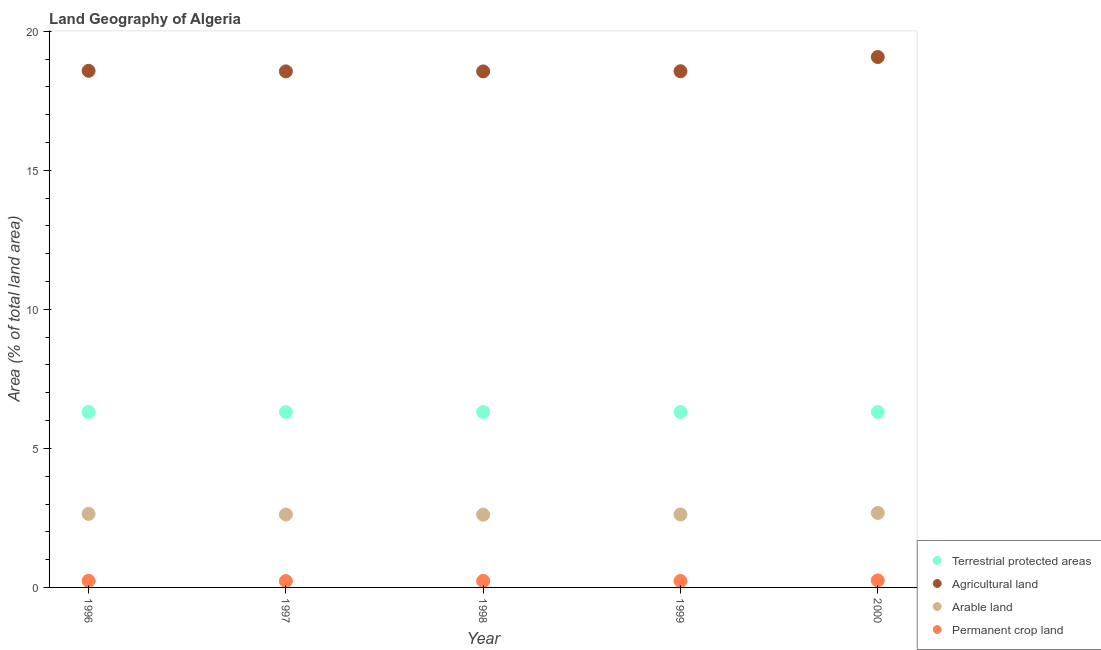What is the percentage of area under agricultural land in 2000?
Offer a terse response. 19.08. Across all years, what is the maximum percentage of area under permanent crop land?
Your response must be concise. 0.25. Across all years, what is the minimum percentage of land under terrestrial protection?
Provide a short and direct response. 6.31. In which year was the percentage of area under arable land maximum?
Keep it short and to the point. 2000. In which year was the percentage of land under terrestrial protection minimum?
Your answer should be very brief. 2000. What is the total percentage of area under arable land in the graph?
Your answer should be compact. 13.19. What is the difference between the percentage of area under agricultural land in 1997 and that in 1998?
Give a very brief answer. 0. What is the difference between the percentage of area under agricultural land in 1997 and the percentage of area under arable land in 2000?
Keep it short and to the point. 15.88. What is the average percentage of land under terrestrial protection per year?
Offer a terse response. 6.31. In the year 1996, what is the difference between the percentage of area under permanent crop land and percentage of area under arable land?
Give a very brief answer. -2.41. In how many years, is the percentage of land under terrestrial protection greater than 4 %?
Provide a short and direct response. 5. What is the ratio of the percentage of area under arable land in 1997 to that in 1998?
Offer a very short reply. 1. Is the percentage of area under arable land in 1998 less than that in 2000?
Your answer should be very brief. Yes. Is the difference between the percentage of area under arable land in 1997 and 1998 greater than the difference between the percentage of area under agricultural land in 1997 and 1998?
Provide a short and direct response. Yes. What is the difference between the highest and the second highest percentage of area under arable land?
Provide a short and direct response. 0.03. What is the difference between the highest and the lowest percentage of area under permanent crop land?
Provide a succinct answer. 0.02. In how many years, is the percentage of area under agricultural land greater than the average percentage of area under agricultural land taken over all years?
Give a very brief answer. 1. Is the sum of the percentage of area under permanent crop land in 1997 and 1998 greater than the maximum percentage of land under terrestrial protection across all years?
Offer a terse response. No. Is it the case that in every year, the sum of the percentage of area under permanent crop land and percentage of area under agricultural land is greater than the sum of percentage of land under terrestrial protection and percentage of area under arable land?
Ensure brevity in your answer.  No. Is it the case that in every year, the sum of the percentage of land under terrestrial protection and percentage of area under agricultural land is greater than the percentage of area under arable land?
Your answer should be compact. Yes. How many dotlines are there?
Offer a very short reply. 4. What is the difference between two consecutive major ticks on the Y-axis?
Your answer should be compact. 5. Where does the legend appear in the graph?
Keep it short and to the point. Bottom right. How are the legend labels stacked?
Your answer should be very brief. Vertical. What is the title of the graph?
Provide a short and direct response. Land Geography of Algeria. Does "Belgium" appear as one of the legend labels in the graph?
Provide a short and direct response. No. What is the label or title of the X-axis?
Provide a short and direct response. Year. What is the label or title of the Y-axis?
Give a very brief answer. Area (% of total land area). What is the Area (% of total land area) in Terrestrial protected areas in 1996?
Provide a succinct answer. 6.31. What is the Area (% of total land area) in Agricultural land in 1996?
Give a very brief answer. 18.58. What is the Area (% of total land area) of Arable land in 1996?
Provide a succinct answer. 2.65. What is the Area (% of total land area) in Permanent crop land in 1996?
Provide a succinct answer. 0.24. What is the Area (% of total land area) of Terrestrial protected areas in 1997?
Your answer should be very brief. 6.31. What is the Area (% of total land area) in Agricultural land in 1997?
Give a very brief answer. 18.56. What is the Area (% of total land area) of Arable land in 1997?
Ensure brevity in your answer.  2.62. What is the Area (% of total land area) of Permanent crop land in 1997?
Your response must be concise. 0.23. What is the Area (% of total land area) in Terrestrial protected areas in 1998?
Your answer should be very brief. 6.31. What is the Area (% of total land area) in Agricultural land in 1998?
Make the answer very short. 18.56. What is the Area (% of total land area) in Arable land in 1998?
Give a very brief answer. 2.62. What is the Area (% of total land area) in Permanent crop land in 1998?
Provide a succinct answer. 0.23. What is the Area (% of total land area) of Terrestrial protected areas in 1999?
Give a very brief answer. 6.31. What is the Area (% of total land area) of Agricultural land in 1999?
Offer a very short reply. 18.56. What is the Area (% of total land area) in Arable land in 1999?
Provide a succinct answer. 2.62. What is the Area (% of total land area) in Permanent crop land in 1999?
Your answer should be very brief. 0.23. What is the Area (% of total land area) in Terrestrial protected areas in 2000?
Provide a short and direct response. 6.31. What is the Area (% of total land area) in Agricultural land in 2000?
Your response must be concise. 19.08. What is the Area (% of total land area) of Arable land in 2000?
Ensure brevity in your answer.  2.68. What is the Area (% of total land area) of Permanent crop land in 2000?
Offer a very short reply. 0.25. Across all years, what is the maximum Area (% of total land area) in Terrestrial protected areas?
Your answer should be compact. 6.31. Across all years, what is the maximum Area (% of total land area) of Agricultural land?
Provide a short and direct response. 19.08. Across all years, what is the maximum Area (% of total land area) in Arable land?
Offer a terse response. 2.68. Across all years, what is the maximum Area (% of total land area) of Permanent crop land?
Provide a short and direct response. 0.25. Across all years, what is the minimum Area (% of total land area) of Terrestrial protected areas?
Provide a succinct answer. 6.31. Across all years, what is the minimum Area (% of total land area) of Agricultural land?
Offer a very short reply. 18.56. Across all years, what is the minimum Area (% of total land area) in Arable land?
Give a very brief answer. 2.62. Across all years, what is the minimum Area (% of total land area) of Permanent crop land?
Your answer should be very brief. 0.23. What is the total Area (% of total land area) in Terrestrial protected areas in the graph?
Keep it short and to the point. 31.54. What is the total Area (% of total land area) of Agricultural land in the graph?
Provide a succinct answer. 93.34. What is the total Area (% of total land area) in Arable land in the graph?
Ensure brevity in your answer.  13.19. What is the total Area (% of total land area) in Permanent crop land in the graph?
Offer a terse response. 1.18. What is the difference between the Area (% of total land area) of Terrestrial protected areas in 1996 and that in 1997?
Provide a short and direct response. 0. What is the difference between the Area (% of total land area) of Agricultural land in 1996 and that in 1997?
Offer a very short reply. 0.02. What is the difference between the Area (% of total land area) of Arable land in 1996 and that in 1997?
Ensure brevity in your answer.  0.02. What is the difference between the Area (% of total land area) of Permanent crop land in 1996 and that in 1997?
Your response must be concise. 0.01. What is the difference between the Area (% of total land area) in Agricultural land in 1996 and that in 1998?
Give a very brief answer. 0.02. What is the difference between the Area (% of total land area) in Arable land in 1996 and that in 1998?
Give a very brief answer. 0.03. What is the difference between the Area (% of total land area) in Permanent crop land in 1996 and that in 1998?
Give a very brief answer. 0. What is the difference between the Area (% of total land area) in Terrestrial protected areas in 1996 and that in 1999?
Give a very brief answer. 0. What is the difference between the Area (% of total land area) in Agricultural land in 1996 and that in 1999?
Make the answer very short. 0.01. What is the difference between the Area (% of total land area) of Arable land in 1996 and that in 1999?
Ensure brevity in your answer.  0.02. What is the difference between the Area (% of total land area) of Permanent crop land in 1996 and that in 1999?
Your answer should be compact. 0.01. What is the difference between the Area (% of total land area) of Agricultural land in 1996 and that in 2000?
Your response must be concise. -0.5. What is the difference between the Area (% of total land area) in Arable land in 1996 and that in 2000?
Your answer should be compact. -0.03. What is the difference between the Area (% of total land area) of Permanent crop land in 1996 and that in 2000?
Give a very brief answer. -0.02. What is the difference between the Area (% of total land area) in Arable land in 1997 and that in 1998?
Offer a terse response. 0. What is the difference between the Area (% of total land area) of Permanent crop land in 1997 and that in 1998?
Your response must be concise. -0. What is the difference between the Area (% of total land area) in Terrestrial protected areas in 1997 and that in 1999?
Your answer should be compact. 0. What is the difference between the Area (% of total land area) of Agricultural land in 1997 and that in 1999?
Give a very brief answer. -0.01. What is the difference between the Area (% of total land area) in Arable land in 1997 and that in 1999?
Provide a short and direct response. -0. What is the difference between the Area (% of total land area) in Permanent crop land in 1997 and that in 1999?
Keep it short and to the point. -0. What is the difference between the Area (% of total land area) in Agricultural land in 1997 and that in 2000?
Your answer should be compact. -0.52. What is the difference between the Area (% of total land area) of Arable land in 1997 and that in 2000?
Your answer should be compact. -0.06. What is the difference between the Area (% of total land area) of Permanent crop land in 1997 and that in 2000?
Make the answer very short. -0.02. What is the difference between the Area (% of total land area) in Terrestrial protected areas in 1998 and that in 1999?
Offer a terse response. 0. What is the difference between the Area (% of total land area) in Agricultural land in 1998 and that in 1999?
Your answer should be very brief. -0.01. What is the difference between the Area (% of total land area) of Arable land in 1998 and that in 1999?
Offer a very short reply. -0.01. What is the difference between the Area (% of total land area) in Permanent crop land in 1998 and that in 1999?
Ensure brevity in your answer.  0. What is the difference between the Area (% of total land area) of Agricultural land in 1998 and that in 2000?
Provide a succinct answer. -0.52. What is the difference between the Area (% of total land area) in Arable land in 1998 and that in 2000?
Offer a terse response. -0.06. What is the difference between the Area (% of total land area) in Permanent crop land in 1998 and that in 2000?
Provide a succinct answer. -0.02. What is the difference between the Area (% of total land area) of Agricultural land in 1999 and that in 2000?
Make the answer very short. -0.51. What is the difference between the Area (% of total land area) in Arable land in 1999 and that in 2000?
Provide a short and direct response. -0.06. What is the difference between the Area (% of total land area) of Permanent crop land in 1999 and that in 2000?
Make the answer very short. -0.02. What is the difference between the Area (% of total land area) of Terrestrial protected areas in 1996 and the Area (% of total land area) of Agricultural land in 1997?
Make the answer very short. -12.25. What is the difference between the Area (% of total land area) in Terrestrial protected areas in 1996 and the Area (% of total land area) in Arable land in 1997?
Your answer should be very brief. 3.69. What is the difference between the Area (% of total land area) of Terrestrial protected areas in 1996 and the Area (% of total land area) of Permanent crop land in 1997?
Provide a short and direct response. 6.08. What is the difference between the Area (% of total land area) of Agricultural land in 1996 and the Area (% of total land area) of Arable land in 1997?
Keep it short and to the point. 15.96. What is the difference between the Area (% of total land area) of Agricultural land in 1996 and the Area (% of total land area) of Permanent crop land in 1997?
Your answer should be compact. 18.35. What is the difference between the Area (% of total land area) of Arable land in 1996 and the Area (% of total land area) of Permanent crop land in 1997?
Make the answer very short. 2.42. What is the difference between the Area (% of total land area) in Terrestrial protected areas in 1996 and the Area (% of total land area) in Agricultural land in 1998?
Ensure brevity in your answer.  -12.25. What is the difference between the Area (% of total land area) of Terrestrial protected areas in 1996 and the Area (% of total land area) of Arable land in 1998?
Keep it short and to the point. 3.69. What is the difference between the Area (% of total land area) in Terrestrial protected areas in 1996 and the Area (% of total land area) in Permanent crop land in 1998?
Make the answer very short. 6.08. What is the difference between the Area (% of total land area) in Agricultural land in 1996 and the Area (% of total land area) in Arable land in 1998?
Your answer should be compact. 15.96. What is the difference between the Area (% of total land area) of Agricultural land in 1996 and the Area (% of total land area) of Permanent crop land in 1998?
Ensure brevity in your answer.  18.35. What is the difference between the Area (% of total land area) in Arable land in 1996 and the Area (% of total land area) in Permanent crop land in 1998?
Offer a terse response. 2.41. What is the difference between the Area (% of total land area) in Terrestrial protected areas in 1996 and the Area (% of total land area) in Agricultural land in 1999?
Offer a very short reply. -12.26. What is the difference between the Area (% of total land area) of Terrestrial protected areas in 1996 and the Area (% of total land area) of Arable land in 1999?
Your answer should be compact. 3.69. What is the difference between the Area (% of total land area) of Terrestrial protected areas in 1996 and the Area (% of total land area) of Permanent crop land in 1999?
Provide a short and direct response. 6.08. What is the difference between the Area (% of total land area) of Agricultural land in 1996 and the Area (% of total land area) of Arable land in 1999?
Offer a terse response. 15.96. What is the difference between the Area (% of total land area) of Agricultural land in 1996 and the Area (% of total land area) of Permanent crop land in 1999?
Provide a short and direct response. 18.35. What is the difference between the Area (% of total land area) in Arable land in 1996 and the Area (% of total land area) in Permanent crop land in 1999?
Ensure brevity in your answer.  2.41. What is the difference between the Area (% of total land area) of Terrestrial protected areas in 1996 and the Area (% of total land area) of Agricultural land in 2000?
Ensure brevity in your answer.  -12.77. What is the difference between the Area (% of total land area) in Terrestrial protected areas in 1996 and the Area (% of total land area) in Arable land in 2000?
Your answer should be very brief. 3.63. What is the difference between the Area (% of total land area) of Terrestrial protected areas in 1996 and the Area (% of total land area) of Permanent crop land in 2000?
Your answer should be compact. 6.06. What is the difference between the Area (% of total land area) of Agricultural land in 1996 and the Area (% of total land area) of Arable land in 2000?
Your answer should be very brief. 15.9. What is the difference between the Area (% of total land area) of Agricultural land in 1996 and the Area (% of total land area) of Permanent crop land in 2000?
Give a very brief answer. 18.33. What is the difference between the Area (% of total land area) in Arable land in 1996 and the Area (% of total land area) in Permanent crop land in 2000?
Your answer should be compact. 2.39. What is the difference between the Area (% of total land area) in Terrestrial protected areas in 1997 and the Area (% of total land area) in Agricultural land in 1998?
Offer a terse response. -12.25. What is the difference between the Area (% of total land area) of Terrestrial protected areas in 1997 and the Area (% of total land area) of Arable land in 1998?
Provide a succinct answer. 3.69. What is the difference between the Area (% of total land area) in Terrestrial protected areas in 1997 and the Area (% of total land area) in Permanent crop land in 1998?
Make the answer very short. 6.08. What is the difference between the Area (% of total land area) of Agricultural land in 1997 and the Area (% of total land area) of Arable land in 1998?
Make the answer very short. 15.94. What is the difference between the Area (% of total land area) of Agricultural land in 1997 and the Area (% of total land area) of Permanent crop land in 1998?
Offer a very short reply. 18.33. What is the difference between the Area (% of total land area) of Arable land in 1997 and the Area (% of total land area) of Permanent crop land in 1998?
Ensure brevity in your answer.  2.39. What is the difference between the Area (% of total land area) in Terrestrial protected areas in 1997 and the Area (% of total land area) in Agricultural land in 1999?
Your answer should be compact. -12.26. What is the difference between the Area (% of total land area) of Terrestrial protected areas in 1997 and the Area (% of total land area) of Arable land in 1999?
Offer a very short reply. 3.69. What is the difference between the Area (% of total land area) in Terrestrial protected areas in 1997 and the Area (% of total land area) in Permanent crop land in 1999?
Your answer should be very brief. 6.08. What is the difference between the Area (% of total land area) of Agricultural land in 1997 and the Area (% of total land area) of Arable land in 1999?
Make the answer very short. 15.94. What is the difference between the Area (% of total land area) in Agricultural land in 1997 and the Area (% of total land area) in Permanent crop land in 1999?
Make the answer very short. 18.33. What is the difference between the Area (% of total land area) in Arable land in 1997 and the Area (% of total land area) in Permanent crop land in 1999?
Your answer should be very brief. 2.39. What is the difference between the Area (% of total land area) of Terrestrial protected areas in 1997 and the Area (% of total land area) of Agricultural land in 2000?
Your answer should be very brief. -12.77. What is the difference between the Area (% of total land area) of Terrestrial protected areas in 1997 and the Area (% of total land area) of Arable land in 2000?
Your response must be concise. 3.63. What is the difference between the Area (% of total land area) in Terrestrial protected areas in 1997 and the Area (% of total land area) in Permanent crop land in 2000?
Your answer should be very brief. 6.06. What is the difference between the Area (% of total land area) of Agricultural land in 1997 and the Area (% of total land area) of Arable land in 2000?
Provide a succinct answer. 15.88. What is the difference between the Area (% of total land area) of Agricultural land in 1997 and the Area (% of total land area) of Permanent crop land in 2000?
Make the answer very short. 18.31. What is the difference between the Area (% of total land area) of Arable land in 1997 and the Area (% of total land area) of Permanent crop land in 2000?
Give a very brief answer. 2.37. What is the difference between the Area (% of total land area) of Terrestrial protected areas in 1998 and the Area (% of total land area) of Agricultural land in 1999?
Provide a short and direct response. -12.26. What is the difference between the Area (% of total land area) of Terrestrial protected areas in 1998 and the Area (% of total land area) of Arable land in 1999?
Your response must be concise. 3.69. What is the difference between the Area (% of total land area) of Terrestrial protected areas in 1998 and the Area (% of total land area) of Permanent crop land in 1999?
Your answer should be compact. 6.08. What is the difference between the Area (% of total land area) of Agricultural land in 1998 and the Area (% of total land area) of Arable land in 1999?
Your response must be concise. 15.94. What is the difference between the Area (% of total land area) in Agricultural land in 1998 and the Area (% of total land area) in Permanent crop land in 1999?
Offer a terse response. 18.33. What is the difference between the Area (% of total land area) of Arable land in 1998 and the Area (% of total land area) of Permanent crop land in 1999?
Your response must be concise. 2.39. What is the difference between the Area (% of total land area) of Terrestrial protected areas in 1998 and the Area (% of total land area) of Agricultural land in 2000?
Offer a very short reply. -12.77. What is the difference between the Area (% of total land area) in Terrestrial protected areas in 1998 and the Area (% of total land area) in Arable land in 2000?
Offer a terse response. 3.63. What is the difference between the Area (% of total land area) in Terrestrial protected areas in 1998 and the Area (% of total land area) in Permanent crop land in 2000?
Your answer should be compact. 6.06. What is the difference between the Area (% of total land area) in Agricultural land in 1998 and the Area (% of total land area) in Arable land in 2000?
Keep it short and to the point. 15.88. What is the difference between the Area (% of total land area) in Agricultural land in 1998 and the Area (% of total land area) in Permanent crop land in 2000?
Provide a short and direct response. 18.31. What is the difference between the Area (% of total land area) of Arable land in 1998 and the Area (% of total land area) of Permanent crop land in 2000?
Keep it short and to the point. 2.36. What is the difference between the Area (% of total land area) in Terrestrial protected areas in 1999 and the Area (% of total land area) in Agricultural land in 2000?
Keep it short and to the point. -12.77. What is the difference between the Area (% of total land area) of Terrestrial protected areas in 1999 and the Area (% of total land area) of Arable land in 2000?
Offer a very short reply. 3.63. What is the difference between the Area (% of total land area) in Terrestrial protected areas in 1999 and the Area (% of total land area) in Permanent crop land in 2000?
Your answer should be very brief. 6.06. What is the difference between the Area (% of total land area) in Agricultural land in 1999 and the Area (% of total land area) in Arable land in 2000?
Keep it short and to the point. 15.89. What is the difference between the Area (% of total land area) in Agricultural land in 1999 and the Area (% of total land area) in Permanent crop land in 2000?
Offer a terse response. 18.31. What is the difference between the Area (% of total land area) of Arable land in 1999 and the Area (% of total land area) of Permanent crop land in 2000?
Your answer should be compact. 2.37. What is the average Area (% of total land area) of Terrestrial protected areas per year?
Keep it short and to the point. 6.31. What is the average Area (% of total land area) in Agricultural land per year?
Your answer should be very brief. 18.67. What is the average Area (% of total land area) of Arable land per year?
Provide a short and direct response. 2.64. What is the average Area (% of total land area) in Permanent crop land per year?
Ensure brevity in your answer.  0.24. In the year 1996, what is the difference between the Area (% of total land area) in Terrestrial protected areas and Area (% of total land area) in Agricultural land?
Give a very brief answer. -12.27. In the year 1996, what is the difference between the Area (% of total land area) in Terrestrial protected areas and Area (% of total land area) in Arable land?
Your answer should be compact. 3.66. In the year 1996, what is the difference between the Area (% of total land area) in Terrestrial protected areas and Area (% of total land area) in Permanent crop land?
Offer a terse response. 6.07. In the year 1996, what is the difference between the Area (% of total land area) in Agricultural land and Area (% of total land area) in Arable land?
Offer a very short reply. 15.93. In the year 1996, what is the difference between the Area (% of total land area) of Agricultural land and Area (% of total land area) of Permanent crop land?
Your response must be concise. 18.34. In the year 1996, what is the difference between the Area (% of total land area) of Arable land and Area (% of total land area) of Permanent crop land?
Give a very brief answer. 2.41. In the year 1997, what is the difference between the Area (% of total land area) of Terrestrial protected areas and Area (% of total land area) of Agricultural land?
Offer a terse response. -12.25. In the year 1997, what is the difference between the Area (% of total land area) of Terrestrial protected areas and Area (% of total land area) of Arable land?
Make the answer very short. 3.69. In the year 1997, what is the difference between the Area (% of total land area) of Terrestrial protected areas and Area (% of total land area) of Permanent crop land?
Offer a terse response. 6.08. In the year 1997, what is the difference between the Area (% of total land area) in Agricultural land and Area (% of total land area) in Arable land?
Provide a succinct answer. 15.94. In the year 1997, what is the difference between the Area (% of total land area) in Agricultural land and Area (% of total land area) in Permanent crop land?
Give a very brief answer. 18.33. In the year 1997, what is the difference between the Area (% of total land area) in Arable land and Area (% of total land area) in Permanent crop land?
Your response must be concise. 2.39. In the year 1998, what is the difference between the Area (% of total land area) in Terrestrial protected areas and Area (% of total land area) in Agricultural land?
Ensure brevity in your answer.  -12.25. In the year 1998, what is the difference between the Area (% of total land area) in Terrestrial protected areas and Area (% of total land area) in Arable land?
Give a very brief answer. 3.69. In the year 1998, what is the difference between the Area (% of total land area) in Terrestrial protected areas and Area (% of total land area) in Permanent crop land?
Offer a terse response. 6.08. In the year 1998, what is the difference between the Area (% of total land area) of Agricultural land and Area (% of total land area) of Arable land?
Ensure brevity in your answer.  15.94. In the year 1998, what is the difference between the Area (% of total land area) in Agricultural land and Area (% of total land area) in Permanent crop land?
Your answer should be very brief. 18.33. In the year 1998, what is the difference between the Area (% of total land area) in Arable land and Area (% of total land area) in Permanent crop land?
Make the answer very short. 2.38. In the year 1999, what is the difference between the Area (% of total land area) of Terrestrial protected areas and Area (% of total land area) of Agricultural land?
Provide a short and direct response. -12.26. In the year 1999, what is the difference between the Area (% of total land area) of Terrestrial protected areas and Area (% of total land area) of Arable land?
Your answer should be very brief. 3.69. In the year 1999, what is the difference between the Area (% of total land area) of Terrestrial protected areas and Area (% of total land area) of Permanent crop land?
Your answer should be very brief. 6.08. In the year 1999, what is the difference between the Area (% of total land area) of Agricultural land and Area (% of total land area) of Arable land?
Ensure brevity in your answer.  15.94. In the year 1999, what is the difference between the Area (% of total land area) in Agricultural land and Area (% of total land area) in Permanent crop land?
Give a very brief answer. 18.33. In the year 1999, what is the difference between the Area (% of total land area) of Arable land and Area (% of total land area) of Permanent crop land?
Make the answer very short. 2.39. In the year 2000, what is the difference between the Area (% of total land area) of Terrestrial protected areas and Area (% of total land area) of Agricultural land?
Provide a succinct answer. -12.77. In the year 2000, what is the difference between the Area (% of total land area) of Terrestrial protected areas and Area (% of total land area) of Arable land?
Give a very brief answer. 3.63. In the year 2000, what is the difference between the Area (% of total land area) in Terrestrial protected areas and Area (% of total land area) in Permanent crop land?
Your answer should be compact. 6.06. In the year 2000, what is the difference between the Area (% of total land area) of Agricultural land and Area (% of total land area) of Arable land?
Give a very brief answer. 16.4. In the year 2000, what is the difference between the Area (% of total land area) of Agricultural land and Area (% of total land area) of Permanent crop land?
Give a very brief answer. 18.82. In the year 2000, what is the difference between the Area (% of total land area) in Arable land and Area (% of total land area) in Permanent crop land?
Your response must be concise. 2.43. What is the ratio of the Area (% of total land area) in Terrestrial protected areas in 1996 to that in 1997?
Keep it short and to the point. 1. What is the ratio of the Area (% of total land area) in Arable land in 1996 to that in 1997?
Ensure brevity in your answer.  1.01. What is the ratio of the Area (% of total land area) in Permanent crop land in 1996 to that in 1997?
Offer a very short reply. 1.04. What is the ratio of the Area (% of total land area) of Agricultural land in 1996 to that in 1998?
Provide a short and direct response. 1. What is the ratio of the Area (% of total land area) in Arable land in 1996 to that in 1998?
Your response must be concise. 1.01. What is the ratio of the Area (% of total land area) of Permanent crop land in 1996 to that in 1998?
Provide a short and direct response. 1.02. What is the ratio of the Area (% of total land area) in Terrestrial protected areas in 1996 to that in 1999?
Provide a short and direct response. 1. What is the ratio of the Area (% of total land area) of Arable land in 1996 to that in 1999?
Give a very brief answer. 1.01. What is the ratio of the Area (% of total land area) of Permanent crop land in 1996 to that in 1999?
Make the answer very short. 1.02. What is the ratio of the Area (% of total land area) in Terrestrial protected areas in 1996 to that in 2000?
Provide a succinct answer. 1. What is the ratio of the Area (% of total land area) in Agricultural land in 1996 to that in 2000?
Provide a short and direct response. 0.97. What is the ratio of the Area (% of total land area) of Arable land in 1996 to that in 2000?
Provide a succinct answer. 0.99. What is the ratio of the Area (% of total land area) in Permanent crop land in 1996 to that in 2000?
Your answer should be compact. 0.94. What is the ratio of the Area (% of total land area) of Terrestrial protected areas in 1997 to that in 1998?
Keep it short and to the point. 1. What is the ratio of the Area (% of total land area) in Arable land in 1997 to that in 1998?
Offer a terse response. 1. What is the ratio of the Area (% of total land area) of Permanent crop land in 1997 to that in 1998?
Your answer should be very brief. 0.98. What is the ratio of the Area (% of total land area) in Arable land in 1997 to that in 1999?
Make the answer very short. 1. What is the ratio of the Area (% of total land area) of Permanent crop land in 1997 to that in 1999?
Your answer should be very brief. 0.99. What is the ratio of the Area (% of total land area) in Agricultural land in 1997 to that in 2000?
Give a very brief answer. 0.97. What is the ratio of the Area (% of total land area) in Arable land in 1997 to that in 2000?
Your answer should be very brief. 0.98. What is the ratio of the Area (% of total land area) of Permanent crop land in 1997 to that in 2000?
Your answer should be very brief. 0.91. What is the ratio of the Area (% of total land area) in Terrestrial protected areas in 1998 to that in 1999?
Offer a very short reply. 1. What is the ratio of the Area (% of total land area) of Arable land in 1998 to that in 1999?
Your answer should be very brief. 1. What is the ratio of the Area (% of total land area) of Agricultural land in 1998 to that in 2000?
Your answer should be very brief. 0.97. What is the ratio of the Area (% of total land area) of Arable land in 1998 to that in 2000?
Make the answer very short. 0.98. What is the ratio of the Area (% of total land area) of Permanent crop land in 1998 to that in 2000?
Your response must be concise. 0.92. What is the ratio of the Area (% of total land area) of Terrestrial protected areas in 1999 to that in 2000?
Ensure brevity in your answer.  1. What is the ratio of the Area (% of total land area) of Agricultural land in 1999 to that in 2000?
Make the answer very short. 0.97. What is the ratio of the Area (% of total land area) in Arable land in 1999 to that in 2000?
Offer a terse response. 0.98. What is the ratio of the Area (% of total land area) in Permanent crop land in 1999 to that in 2000?
Keep it short and to the point. 0.92. What is the difference between the highest and the second highest Area (% of total land area) of Agricultural land?
Keep it short and to the point. 0.5. What is the difference between the highest and the second highest Area (% of total land area) of Arable land?
Keep it short and to the point. 0.03. What is the difference between the highest and the second highest Area (% of total land area) in Permanent crop land?
Make the answer very short. 0.02. What is the difference between the highest and the lowest Area (% of total land area) in Agricultural land?
Your answer should be compact. 0.52. What is the difference between the highest and the lowest Area (% of total land area) in Arable land?
Keep it short and to the point. 0.06. What is the difference between the highest and the lowest Area (% of total land area) in Permanent crop land?
Give a very brief answer. 0.02. 